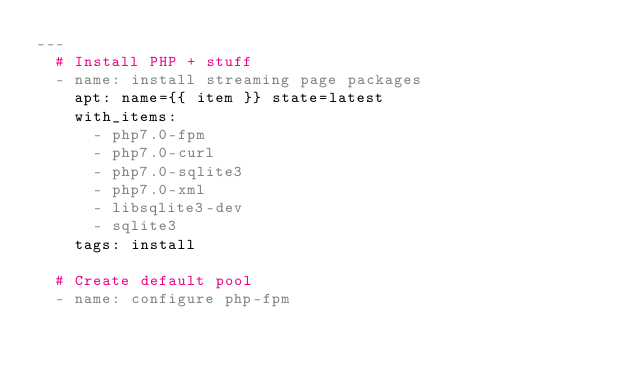<code> <loc_0><loc_0><loc_500><loc_500><_YAML_>---
  # Install PHP + stuff
  - name: install streaming page packages
    apt: name={{ item }} state=latest
    with_items:
      - php7.0-fpm
      - php7.0-curl
      - php7.0-sqlite3
      - php7.0-xml
      - libsqlite3-dev
      - sqlite3
    tags: install

  # Create default pool
  - name: configure php-fpm</code> 